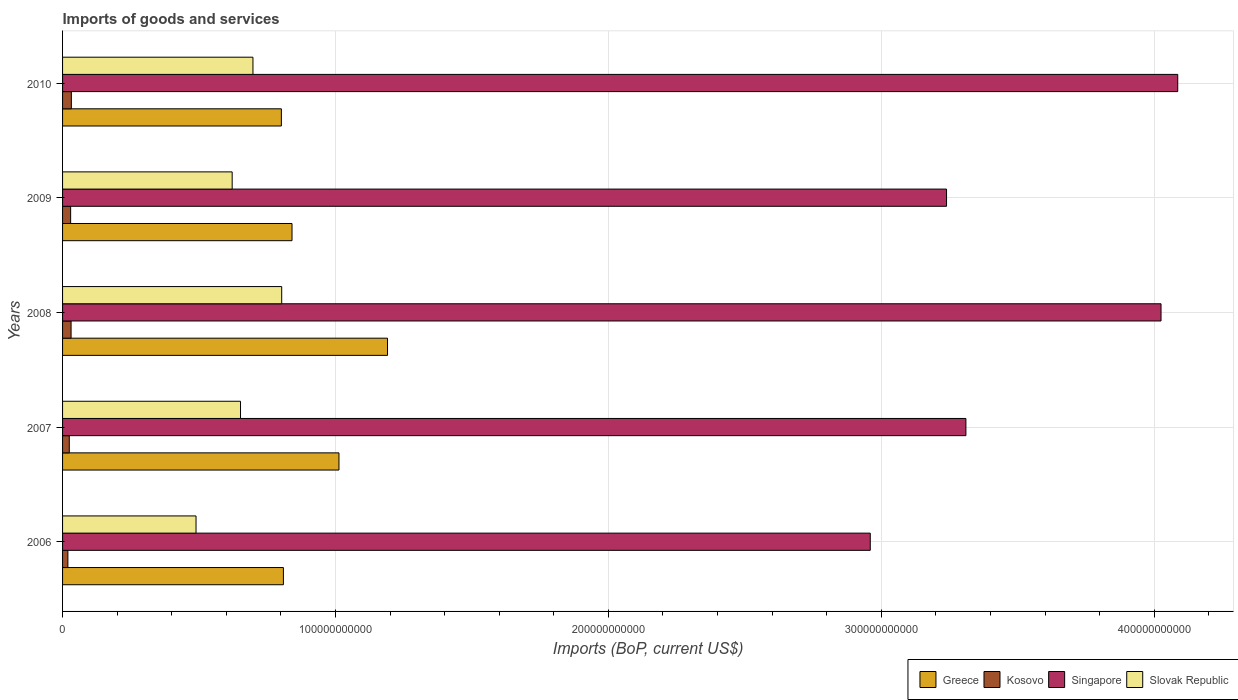Are the number of bars on each tick of the Y-axis equal?
Ensure brevity in your answer.  Yes. How many bars are there on the 1st tick from the bottom?
Give a very brief answer. 4. What is the amount spent on imports in Slovak Republic in 2010?
Make the answer very short. 6.98e+1. Across all years, what is the maximum amount spent on imports in Greece?
Ensure brevity in your answer.  1.19e+11. Across all years, what is the minimum amount spent on imports in Greece?
Your answer should be compact. 8.02e+1. In which year was the amount spent on imports in Singapore maximum?
Provide a short and direct response. 2010. In which year was the amount spent on imports in Slovak Republic minimum?
Your answer should be very brief. 2006. What is the total amount spent on imports in Slovak Republic in the graph?
Ensure brevity in your answer.  3.26e+11. What is the difference between the amount spent on imports in Singapore in 2006 and that in 2009?
Keep it short and to the point. -2.80e+1. What is the difference between the amount spent on imports in Slovak Republic in 2010 and the amount spent on imports in Singapore in 2009?
Offer a very short reply. -2.54e+11. What is the average amount spent on imports in Kosovo per year?
Give a very brief answer. 2.74e+09. In the year 2010, what is the difference between the amount spent on imports in Slovak Republic and amount spent on imports in Kosovo?
Your answer should be compact. 6.65e+1. What is the ratio of the amount spent on imports in Singapore in 2006 to that in 2010?
Make the answer very short. 0.72. Is the amount spent on imports in Slovak Republic in 2007 less than that in 2008?
Ensure brevity in your answer.  Yes. Is the difference between the amount spent on imports in Slovak Republic in 2006 and 2009 greater than the difference between the amount spent on imports in Kosovo in 2006 and 2009?
Your answer should be very brief. No. What is the difference between the highest and the second highest amount spent on imports in Kosovo?
Provide a short and direct response. 1.03e+08. What is the difference between the highest and the lowest amount spent on imports in Singapore?
Your response must be concise. 1.13e+11. In how many years, is the amount spent on imports in Kosovo greater than the average amount spent on imports in Kosovo taken over all years?
Provide a succinct answer. 3. Is the sum of the amount spent on imports in Greece in 2007 and 2008 greater than the maximum amount spent on imports in Singapore across all years?
Your answer should be very brief. No. Is it the case that in every year, the sum of the amount spent on imports in Greece and amount spent on imports in Slovak Republic is greater than the sum of amount spent on imports in Singapore and amount spent on imports in Kosovo?
Provide a succinct answer. Yes. What does the 1st bar from the top in 2007 represents?
Provide a succinct answer. Slovak Republic. What does the 3rd bar from the bottom in 2006 represents?
Ensure brevity in your answer.  Singapore. How many bars are there?
Provide a short and direct response. 20. How many years are there in the graph?
Your answer should be very brief. 5. What is the difference between two consecutive major ticks on the X-axis?
Your answer should be compact. 1.00e+11. Are the values on the major ticks of X-axis written in scientific E-notation?
Give a very brief answer. No. Does the graph contain grids?
Ensure brevity in your answer.  Yes. Where does the legend appear in the graph?
Your answer should be compact. Bottom right. How many legend labels are there?
Offer a very short reply. 4. What is the title of the graph?
Offer a very short reply. Imports of goods and services. What is the label or title of the X-axis?
Your answer should be very brief. Imports (BoP, current US$). What is the label or title of the Y-axis?
Ensure brevity in your answer.  Years. What is the Imports (BoP, current US$) in Greece in 2006?
Ensure brevity in your answer.  8.09e+1. What is the Imports (BoP, current US$) of Kosovo in 2006?
Provide a succinct answer. 1.95e+09. What is the Imports (BoP, current US$) in Singapore in 2006?
Offer a terse response. 2.96e+11. What is the Imports (BoP, current US$) of Slovak Republic in 2006?
Make the answer very short. 4.89e+1. What is the Imports (BoP, current US$) in Greece in 2007?
Your answer should be compact. 1.01e+11. What is the Imports (BoP, current US$) in Kosovo in 2007?
Ensure brevity in your answer.  2.46e+09. What is the Imports (BoP, current US$) in Singapore in 2007?
Give a very brief answer. 3.31e+11. What is the Imports (BoP, current US$) in Slovak Republic in 2007?
Provide a succinct answer. 6.52e+1. What is the Imports (BoP, current US$) in Greece in 2008?
Provide a short and direct response. 1.19e+11. What is the Imports (BoP, current US$) of Kosovo in 2008?
Give a very brief answer. 3.12e+09. What is the Imports (BoP, current US$) of Singapore in 2008?
Ensure brevity in your answer.  4.03e+11. What is the Imports (BoP, current US$) in Slovak Republic in 2008?
Provide a short and direct response. 8.03e+1. What is the Imports (BoP, current US$) of Greece in 2009?
Keep it short and to the point. 8.41e+1. What is the Imports (BoP, current US$) in Kosovo in 2009?
Ensure brevity in your answer.  2.96e+09. What is the Imports (BoP, current US$) of Singapore in 2009?
Your response must be concise. 3.24e+11. What is the Imports (BoP, current US$) of Slovak Republic in 2009?
Offer a very short reply. 6.21e+1. What is the Imports (BoP, current US$) of Greece in 2010?
Your answer should be compact. 8.02e+1. What is the Imports (BoP, current US$) in Kosovo in 2010?
Keep it short and to the point. 3.22e+09. What is the Imports (BoP, current US$) of Singapore in 2010?
Keep it short and to the point. 4.09e+11. What is the Imports (BoP, current US$) in Slovak Republic in 2010?
Provide a short and direct response. 6.98e+1. Across all years, what is the maximum Imports (BoP, current US$) in Greece?
Your answer should be compact. 1.19e+11. Across all years, what is the maximum Imports (BoP, current US$) of Kosovo?
Offer a very short reply. 3.22e+09. Across all years, what is the maximum Imports (BoP, current US$) in Singapore?
Ensure brevity in your answer.  4.09e+11. Across all years, what is the maximum Imports (BoP, current US$) in Slovak Republic?
Offer a very short reply. 8.03e+1. Across all years, what is the minimum Imports (BoP, current US$) in Greece?
Offer a very short reply. 8.02e+1. Across all years, what is the minimum Imports (BoP, current US$) of Kosovo?
Make the answer very short. 1.95e+09. Across all years, what is the minimum Imports (BoP, current US$) in Singapore?
Ensure brevity in your answer.  2.96e+11. Across all years, what is the minimum Imports (BoP, current US$) of Slovak Republic?
Your answer should be compact. 4.89e+1. What is the total Imports (BoP, current US$) of Greece in the graph?
Ensure brevity in your answer.  4.66e+11. What is the total Imports (BoP, current US$) of Kosovo in the graph?
Your response must be concise. 1.37e+1. What is the total Imports (BoP, current US$) of Singapore in the graph?
Your answer should be compact. 1.76e+12. What is the total Imports (BoP, current US$) in Slovak Republic in the graph?
Make the answer very short. 3.26e+11. What is the difference between the Imports (BoP, current US$) of Greece in 2006 and that in 2007?
Keep it short and to the point. -2.04e+1. What is the difference between the Imports (BoP, current US$) of Kosovo in 2006 and that in 2007?
Your answer should be very brief. -5.10e+08. What is the difference between the Imports (BoP, current US$) in Singapore in 2006 and that in 2007?
Ensure brevity in your answer.  -3.50e+1. What is the difference between the Imports (BoP, current US$) in Slovak Republic in 2006 and that in 2007?
Offer a terse response. -1.63e+1. What is the difference between the Imports (BoP, current US$) in Greece in 2006 and that in 2008?
Your response must be concise. -3.81e+1. What is the difference between the Imports (BoP, current US$) of Kosovo in 2006 and that in 2008?
Ensure brevity in your answer.  -1.17e+09. What is the difference between the Imports (BoP, current US$) of Singapore in 2006 and that in 2008?
Keep it short and to the point. -1.07e+11. What is the difference between the Imports (BoP, current US$) of Slovak Republic in 2006 and that in 2008?
Give a very brief answer. -3.14e+1. What is the difference between the Imports (BoP, current US$) of Greece in 2006 and that in 2009?
Your answer should be very brief. -3.16e+09. What is the difference between the Imports (BoP, current US$) of Kosovo in 2006 and that in 2009?
Provide a succinct answer. -1.01e+09. What is the difference between the Imports (BoP, current US$) in Singapore in 2006 and that in 2009?
Offer a very short reply. -2.80e+1. What is the difference between the Imports (BoP, current US$) in Slovak Republic in 2006 and that in 2009?
Offer a very short reply. -1.32e+1. What is the difference between the Imports (BoP, current US$) of Greece in 2006 and that in 2010?
Offer a terse response. 7.44e+08. What is the difference between the Imports (BoP, current US$) in Kosovo in 2006 and that in 2010?
Your answer should be very brief. -1.27e+09. What is the difference between the Imports (BoP, current US$) of Singapore in 2006 and that in 2010?
Give a very brief answer. -1.13e+11. What is the difference between the Imports (BoP, current US$) of Slovak Republic in 2006 and that in 2010?
Your answer should be very brief. -2.09e+1. What is the difference between the Imports (BoP, current US$) of Greece in 2007 and that in 2008?
Your answer should be compact. -1.78e+1. What is the difference between the Imports (BoP, current US$) of Kosovo in 2007 and that in 2008?
Your response must be concise. -6.61e+08. What is the difference between the Imports (BoP, current US$) of Singapore in 2007 and that in 2008?
Provide a succinct answer. -7.15e+1. What is the difference between the Imports (BoP, current US$) in Slovak Republic in 2007 and that in 2008?
Make the answer very short. -1.51e+1. What is the difference between the Imports (BoP, current US$) in Greece in 2007 and that in 2009?
Offer a very short reply. 1.72e+1. What is the difference between the Imports (BoP, current US$) of Kosovo in 2007 and that in 2009?
Your answer should be compact. -5.01e+08. What is the difference between the Imports (BoP, current US$) in Singapore in 2007 and that in 2009?
Ensure brevity in your answer.  7.10e+09. What is the difference between the Imports (BoP, current US$) of Slovak Republic in 2007 and that in 2009?
Your answer should be compact. 3.06e+09. What is the difference between the Imports (BoP, current US$) of Greece in 2007 and that in 2010?
Your answer should be compact. 2.11e+1. What is the difference between the Imports (BoP, current US$) in Kosovo in 2007 and that in 2010?
Your response must be concise. -7.63e+08. What is the difference between the Imports (BoP, current US$) in Singapore in 2007 and that in 2010?
Give a very brief answer. -7.76e+1. What is the difference between the Imports (BoP, current US$) in Slovak Republic in 2007 and that in 2010?
Your answer should be very brief. -4.56e+09. What is the difference between the Imports (BoP, current US$) of Greece in 2008 and that in 2009?
Give a very brief answer. 3.50e+1. What is the difference between the Imports (BoP, current US$) in Kosovo in 2008 and that in 2009?
Your answer should be compact. 1.59e+08. What is the difference between the Imports (BoP, current US$) in Singapore in 2008 and that in 2009?
Your answer should be compact. 7.86e+1. What is the difference between the Imports (BoP, current US$) of Slovak Republic in 2008 and that in 2009?
Provide a succinct answer. 1.81e+1. What is the difference between the Imports (BoP, current US$) of Greece in 2008 and that in 2010?
Offer a terse response. 3.89e+1. What is the difference between the Imports (BoP, current US$) in Kosovo in 2008 and that in 2010?
Your answer should be very brief. -1.03e+08. What is the difference between the Imports (BoP, current US$) of Singapore in 2008 and that in 2010?
Offer a terse response. -6.12e+09. What is the difference between the Imports (BoP, current US$) of Slovak Republic in 2008 and that in 2010?
Your answer should be compact. 1.05e+1. What is the difference between the Imports (BoP, current US$) in Greece in 2009 and that in 2010?
Offer a very short reply. 3.90e+09. What is the difference between the Imports (BoP, current US$) of Kosovo in 2009 and that in 2010?
Offer a very short reply. -2.62e+08. What is the difference between the Imports (BoP, current US$) in Singapore in 2009 and that in 2010?
Your answer should be compact. -8.47e+1. What is the difference between the Imports (BoP, current US$) of Slovak Republic in 2009 and that in 2010?
Offer a terse response. -7.61e+09. What is the difference between the Imports (BoP, current US$) of Greece in 2006 and the Imports (BoP, current US$) of Kosovo in 2007?
Ensure brevity in your answer.  7.85e+1. What is the difference between the Imports (BoP, current US$) in Greece in 2006 and the Imports (BoP, current US$) in Singapore in 2007?
Keep it short and to the point. -2.50e+11. What is the difference between the Imports (BoP, current US$) in Greece in 2006 and the Imports (BoP, current US$) in Slovak Republic in 2007?
Your response must be concise. 1.57e+1. What is the difference between the Imports (BoP, current US$) in Kosovo in 2006 and the Imports (BoP, current US$) in Singapore in 2007?
Provide a short and direct response. -3.29e+11. What is the difference between the Imports (BoP, current US$) in Kosovo in 2006 and the Imports (BoP, current US$) in Slovak Republic in 2007?
Offer a terse response. -6.33e+1. What is the difference between the Imports (BoP, current US$) of Singapore in 2006 and the Imports (BoP, current US$) of Slovak Republic in 2007?
Your response must be concise. 2.31e+11. What is the difference between the Imports (BoP, current US$) of Greece in 2006 and the Imports (BoP, current US$) of Kosovo in 2008?
Offer a terse response. 7.78e+1. What is the difference between the Imports (BoP, current US$) in Greece in 2006 and the Imports (BoP, current US$) in Singapore in 2008?
Your answer should be compact. -3.22e+11. What is the difference between the Imports (BoP, current US$) in Greece in 2006 and the Imports (BoP, current US$) in Slovak Republic in 2008?
Offer a terse response. 6.22e+08. What is the difference between the Imports (BoP, current US$) of Kosovo in 2006 and the Imports (BoP, current US$) of Singapore in 2008?
Offer a very short reply. -4.01e+11. What is the difference between the Imports (BoP, current US$) in Kosovo in 2006 and the Imports (BoP, current US$) in Slovak Republic in 2008?
Ensure brevity in your answer.  -7.83e+1. What is the difference between the Imports (BoP, current US$) in Singapore in 2006 and the Imports (BoP, current US$) in Slovak Republic in 2008?
Provide a short and direct response. 2.16e+11. What is the difference between the Imports (BoP, current US$) of Greece in 2006 and the Imports (BoP, current US$) of Kosovo in 2009?
Keep it short and to the point. 7.80e+1. What is the difference between the Imports (BoP, current US$) of Greece in 2006 and the Imports (BoP, current US$) of Singapore in 2009?
Offer a very short reply. -2.43e+11. What is the difference between the Imports (BoP, current US$) of Greece in 2006 and the Imports (BoP, current US$) of Slovak Republic in 2009?
Offer a terse response. 1.88e+1. What is the difference between the Imports (BoP, current US$) of Kosovo in 2006 and the Imports (BoP, current US$) of Singapore in 2009?
Offer a very short reply. -3.22e+11. What is the difference between the Imports (BoP, current US$) in Kosovo in 2006 and the Imports (BoP, current US$) in Slovak Republic in 2009?
Provide a short and direct response. -6.02e+1. What is the difference between the Imports (BoP, current US$) in Singapore in 2006 and the Imports (BoP, current US$) in Slovak Republic in 2009?
Your response must be concise. 2.34e+11. What is the difference between the Imports (BoP, current US$) in Greece in 2006 and the Imports (BoP, current US$) in Kosovo in 2010?
Make the answer very short. 7.77e+1. What is the difference between the Imports (BoP, current US$) in Greece in 2006 and the Imports (BoP, current US$) in Singapore in 2010?
Provide a short and direct response. -3.28e+11. What is the difference between the Imports (BoP, current US$) in Greece in 2006 and the Imports (BoP, current US$) in Slovak Republic in 2010?
Provide a succinct answer. 1.12e+1. What is the difference between the Imports (BoP, current US$) of Kosovo in 2006 and the Imports (BoP, current US$) of Singapore in 2010?
Keep it short and to the point. -4.07e+11. What is the difference between the Imports (BoP, current US$) of Kosovo in 2006 and the Imports (BoP, current US$) of Slovak Republic in 2010?
Offer a terse response. -6.78e+1. What is the difference between the Imports (BoP, current US$) of Singapore in 2006 and the Imports (BoP, current US$) of Slovak Republic in 2010?
Offer a terse response. 2.26e+11. What is the difference between the Imports (BoP, current US$) of Greece in 2007 and the Imports (BoP, current US$) of Kosovo in 2008?
Your answer should be very brief. 9.82e+1. What is the difference between the Imports (BoP, current US$) of Greece in 2007 and the Imports (BoP, current US$) of Singapore in 2008?
Give a very brief answer. -3.01e+11. What is the difference between the Imports (BoP, current US$) of Greece in 2007 and the Imports (BoP, current US$) of Slovak Republic in 2008?
Make the answer very short. 2.10e+1. What is the difference between the Imports (BoP, current US$) of Kosovo in 2007 and the Imports (BoP, current US$) of Singapore in 2008?
Give a very brief answer. -4.00e+11. What is the difference between the Imports (BoP, current US$) in Kosovo in 2007 and the Imports (BoP, current US$) in Slovak Republic in 2008?
Offer a very short reply. -7.78e+1. What is the difference between the Imports (BoP, current US$) of Singapore in 2007 and the Imports (BoP, current US$) of Slovak Republic in 2008?
Your answer should be compact. 2.51e+11. What is the difference between the Imports (BoP, current US$) of Greece in 2007 and the Imports (BoP, current US$) of Kosovo in 2009?
Provide a short and direct response. 9.83e+1. What is the difference between the Imports (BoP, current US$) of Greece in 2007 and the Imports (BoP, current US$) of Singapore in 2009?
Your response must be concise. -2.23e+11. What is the difference between the Imports (BoP, current US$) in Greece in 2007 and the Imports (BoP, current US$) in Slovak Republic in 2009?
Ensure brevity in your answer.  3.91e+1. What is the difference between the Imports (BoP, current US$) in Kosovo in 2007 and the Imports (BoP, current US$) in Singapore in 2009?
Offer a very short reply. -3.21e+11. What is the difference between the Imports (BoP, current US$) in Kosovo in 2007 and the Imports (BoP, current US$) in Slovak Republic in 2009?
Provide a succinct answer. -5.97e+1. What is the difference between the Imports (BoP, current US$) in Singapore in 2007 and the Imports (BoP, current US$) in Slovak Republic in 2009?
Ensure brevity in your answer.  2.69e+11. What is the difference between the Imports (BoP, current US$) in Greece in 2007 and the Imports (BoP, current US$) in Kosovo in 2010?
Offer a very short reply. 9.81e+1. What is the difference between the Imports (BoP, current US$) of Greece in 2007 and the Imports (BoP, current US$) of Singapore in 2010?
Give a very brief answer. -3.07e+11. What is the difference between the Imports (BoP, current US$) in Greece in 2007 and the Imports (BoP, current US$) in Slovak Republic in 2010?
Provide a succinct answer. 3.15e+1. What is the difference between the Imports (BoP, current US$) in Kosovo in 2007 and the Imports (BoP, current US$) in Singapore in 2010?
Your answer should be very brief. -4.06e+11. What is the difference between the Imports (BoP, current US$) in Kosovo in 2007 and the Imports (BoP, current US$) in Slovak Republic in 2010?
Ensure brevity in your answer.  -6.73e+1. What is the difference between the Imports (BoP, current US$) in Singapore in 2007 and the Imports (BoP, current US$) in Slovak Republic in 2010?
Ensure brevity in your answer.  2.61e+11. What is the difference between the Imports (BoP, current US$) of Greece in 2008 and the Imports (BoP, current US$) of Kosovo in 2009?
Offer a very short reply. 1.16e+11. What is the difference between the Imports (BoP, current US$) in Greece in 2008 and the Imports (BoP, current US$) in Singapore in 2009?
Make the answer very short. -2.05e+11. What is the difference between the Imports (BoP, current US$) in Greece in 2008 and the Imports (BoP, current US$) in Slovak Republic in 2009?
Make the answer very short. 5.69e+1. What is the difference between the Imports (BoP, current US$) in Kosovo in 2008 and the Imports (BoP, current US$) in Singapore in 2009?
Give a very brief answer. -3.21e+11. What is the difference between the Imports (BoP, current US$) of Kosovo in 2008 and the Imports (BoP, current US$) of Slovak Republic in 2009?
Offer a terse response. -5.90e+1. What is the difference between the Imports (BoP, current US$) of Singapore in 2008 and the Imports (BoP, current US$) of Slovak Republic in 2009?
Ensure brevity in your answer.  3.40e+11. What is the difference between the Imports (BoP, current US$) of Greece in 2008 and the Imports (BoP, current US$) of Kosovo in 2010?
Offer a terse response. 1.16e+11. What is the difference between the Imports (BoP, current US$) in Greece in 2008 and the Imports (BoP, current US$) in Singapore in 2010?
Your response must be concise. -2.90e+11. What is the difference between the Imports (BoP, current US$) of Greece in 2008 and the Imports (BoP, current US$) of Slovak Republic in 2010?
Make the answer very short. 4.93e+1. What is the difference between the Imports (BoP, current US$) of Kosovo in 2008 and the Imports (BoP, current US$) of Singapore in 2010?
Ensure brevity in your answer.  -4.06e+11. What is the difference between the Imports (BoP, current US$) in Kosovo in 2008 and the Imports (BoP, current US$) in Slovak Republic in 2010?
Make the answer very short. -6.66e+1. What is the difference between the Imports (BoP, current US$) in Singapore in 2008 and the Imports (BoP, current US$) in Slovak Republic in 2010?
Keep it short and to the point. 3.33e+11. What is the difference between the Imports (BoP, current US$) in Greece in 2009 and the Imports (BoP, current US$) in Kosovo in 2010?
Keep it short and to the point. 8.09e+1. What is the difference between the Imports (BoP, current US$) in Greece in 2009 and the Imports (BoP, current US$) in Singapore in 2010?
Your answer should be very brief. -3.25e+11. What is the difference between the Imports (BoP, current US$) of Greece in 2009 and the Imports (BoP, current US$) of Slovak Republic in 2010?
Your answer should be very brief. 1.43e+1. What is the difference between the Imports (BoP, current US$) in Kosovo in 2009 and the Imports (BoP, current US$) in Singapore in 2010?
Your answer should be compact. -4.06e+11. What is the difference between the Imports (BoP, current US$) in Kosovo in 2009 and the Imports (BoP, current US$) in Slovak Republic in 2010?
Make the answer very short. -6.68e+1. What is the difference between the Imports (BoP, current US$) of Singapore in 2009 and the Imports (BoP, current US$) of Slovak Republic in 2010?
Keep it short and to the point. 2.54e+11. What is the average Imports (BoP, current US$) in Greece per year?
Provide a succinct answer. 9.31e+1. What is the average Imports (BoP, current US$) in Kosovo per year?
Give a very brief answer. 2.74e+09. What is the average Imports (BoP, current US$) in Singapore per year?
Offer a very short reply. 3.52e+11. What is the average Imports (BoP, current US$) in Slovak Republic per year?
Offer a very short reply. 6.53e+1. In the year 2006, what is the difference between the Imports (BoP, current US$) of Greece and Imports (BoP, current US$) of Kosovo?
Provide a short and direct response. 7.90e+1. In the year 2006, what is the difference between the Imports (BoP, current US$) of Greece and Imports (BoP, current US$) of Singapore?
Offer a terse response. -2.15e+11. In the year 2006, what is the difference between the Imports (BoP, current US$) of Greece and Imports (BoP, current US$) of Slovak Republic?
Offer a very short reply. 3.20e+1. In the year 2006, what is the difference between the Imports (BoP, current US$) of Kosovo and Imports (BoP, current US$) of Singapore?
Your response must be concise. -2.94e+11. In the year 2006, what is the difference between the Imports (BoP, current US$) of Kosovo and Imports (BoP, current US$) of Slovak Republic?
Make the answer very short. -4.70e+1. In the year 2006, what is the difference between the Imports (BoP, current US$) of Singapore and Imports (BoP, current US$) of Slovak Republic?
Make the answer very short. 2.47e+11. In the year 2007, what is the difference between the Imports (BoP, current US$) of Greece and Imports (BoP, current US$) of Kosovo?
Ensure brevity in your answer.  9.88e+1. In the year 2007, what is the difference between the Imports (BoP, current US$) of Greece and Imports (BoP, current US$) of Singapore?
Your answer should be compact. -2.30e+11. In the year 2007, what is the difference between the Imports (BoP, current US$) in Greece and Imports (BoP, current US$) in Slovak Republic?
Give a very brief answer. 3.61e+1. In the year 2007, what is the difference between the Imports (BoP, current US$) in Kosovo and Imports (BoP, current US$) in Singapore?
Make the answer very short. -3.29e+11. In the year 2007, what is the difference between the Imports (BoP, current US$) of Kosovo and Imports (BoP, current US$) of Slovak Republic?
Give a very brief answer. -6.27e+1. In the year 2007, what is the difference between the Imports (BoP, current US$) of Singapore and Imports (BoP, current US$) of Slovak Republic?
Your answer should be very brief. 2.66e+11. In the year 2008, what is the difference between the Imports (BoP, current US$) of Greece and Imports (BoP, current US$) of Kosovo?
Give a very brief answer. 1.16e+11. In the year 2008, what is the difference between the Imports (BoP, current US$) of Greece and Imports (BoP, current US$) of Singapore?
Your answer should be very brief. -2.83e+11. In the year 2008, what is the difference between the Imports (BoP, current US$) in Greece and Imports (BoP, current US$) in Slovak Republic?
Offer a terse response. 3.88e+1. In the year 2008, what is the difference between the Imports (BoP, current US$) of Kosovo and Imports (BoP, current US$) of Singapore?
Give a very brief answer. -3.99e+11. In the year 2008, what is the difference between the Imports (BoP, current US$) in Kosovo and Imports (BoP, current US$) in Slovak Republic?
Your response must be concise. -7.72e+1. In the year 2008, what is the difference between the Imports (BoP, current US$) in Singapore and Imports (BoP, current US$) in Slovak Republic?
Offer a terse response. 3.22e+11. In the year 2009, what is the difference between the Imports (BoP, current US$) of Greece and Imports (BoP, current US$) of Kosovo?
Ensure brevity in your answer.  8.11e+1. In the year 2009, what is the difference between the Imports (BoP, current US$) of Greece and Imports (BoP, current US$) of Singapore?
Make the answer very short. -2.40e+11. In the year 2009, what is the difference between the Imports (BoP, current US$) in Greece and Imports (BoP, current US$) in Slovak Republic?
Provide a short and direct response. 2.19e+1. In the year 2009, what is the difference between the Imports (BoP, current US$) in Kosovo and Imports (BoP, current US$) in Singapore?
Offer a very short reply. -3.21e+11. In the year 2009, what is the difference between the Imports (BoP, current US$) of Kosovo and Imports (BoP, current US$) of Slovak Republic?
Your response must be concise. -5.92e+1. In the year 2009, what is the difference between the Imports (BoP, current US$) in Singapore and Imports (BoP, current US$) in Slovak Republic?
Your response must be concise. 2.62e+11. In the year 2010, what is the difference between the Imports (BoP, current US$) in Greece and Imports (BoP, current US$) in Kosovo?
Give a very brief answer. 7.70e+1. In the year 2010, what is the difference between the Imports (BoP, current US$) of Greece and Imports (BoP, current US$) of Singapore?
Provide a succinct answer. -3.28e+11. In the year 2010, what is the difference between the Imports (BoP, current US$) of Greece and Imports (BoP, current US$) of Slovak Republic?
Your answer should be compact. 1.04e+1. In the year 2010, what is the difference between the Imports (BoP, current US$) in Kosovo and Imports (BoP, current US$) in Singapore?
Make the answer very short. -4.05e+11. In the year 2010, what is the difference between the Imports (BoP, current US$) of Kosovo and Imports (BoP, current US$) of Slovak Republic?
Your answer should be very brief. -6.65e+1. In the year 2010, what is the difference between the Imports (BoP, current US$) of Singapore and Imports (BoP, current US$) of Slovak Republic?
Keep it short and to the point. 3.39e+11. What is the ratio of the Imports (BoP, current US$) in Greece in 2006 to that in 2007?
Make the answer very short. 0.8. What is the ratio of the Imports (BoP, current US$) of Kosovo in 2006 to that in 2007?
Offer a very short reply. 0.79. What is the ratio of the Imports (BoP, current US$) in Singapore in 2006 to that in 2007?
Keep it short and to the point. 0.89. What is the ratio of the Imports (BoP, current US$) in Slovak Republic in 2006 to that in 2007?
Make the answer very short. 0.75. What is the ratio of the Imports (BoP, current US$) of Greece in 2006 to that in 2008?
Provide a succinct answer. 0.68. What is the ratio of the Imports (BoP, current US$) in Kosovo in 2006 to that in 2008?
Ensure brevity in your answer.  0.62. What is the ratio of the Imports (BoP, current US$) of Singapore in 2006 to that in 2008?
Your answer should be very brief. 0.74. What is the ratio of the Imports (BoP, current US$) in Slovak Republic in 2006 to that in 2008?
Offer a terse response. 0.61. What is the ratio of the Imports (BoP, current US$) in Greece in 2006 to that in 2009?
Your answer should be compact. 0.96. What is the ratio of the Imports (BoP, current US$) of Kosovo in 2006 to that in 2009?
Your response must be concise. 0.66. What is the ratio of the Imports (BoP, current US$) in Singapore in 2006 to that in 2009?
Give a very brief answer. 0.91. What is the ratio of the Imports (BoP, current US$) in Slovak Republic in 2006 to that in 2009?
Ensure brevity in your answer.  0.79. What is the ratio of the Imports (BoP, current US$) of Greece in 2006 to that in 2010?
Keep it short and to the point. 1.01. What is the ratio of the Imports (BoP, current US$) of Kosovo in 2006 to that in 2010?
Offer a very short reply. 0.6. What is the ratio of the Imports (BoP, current US$) of Singapore in 2006 to that in 2010?
Offer a terse response. 0.72. What is the ratio of the Imports (BoP, current US$) in Slovak Republic in 2006 to that in 2010?
Provide a succinct answer. 0.7. What is the ratio of the Imports (BoP, current US$) of Greece in 2007 to that in 2008?
Your response must be concise. 0.85. What is the ratio of the Imports (BoP, current US$) of Kosovo in 2007 to that in 2008?
Offer a very short reply. 0.79. What is the ratio of the Imports (BoP, current US$) in Singapore in 2007 to that in 2008?
Your answer should be very brief. 0.82. What is the ratio of the Imports (BoP, current US$) in Slovak Republic in 2007 to that in 2008?
Provide a short and direct response. 0.81. What is the ratio of the Imports (BoP, current US$) of Greece in 2007 to that in 2009?
Provide a short and direct response. 1.2. What is the ratio of the Imports (BoP, current US$) of Kosovo in 2007 to that in 2009?
Keep it short and to the point. 0.83. What is the ratio of the Imports (BoP, current US$) of Singapore in 2007 to that in 2009?
Ensure brevity in your answer.  1.02. What is the ratio of the Imports (BoP, current US$) of Slovak Republic in 2007 to that in 2009?
Provide a succinct answer. 1.05. What is the ratio of the Imports (BoP, current US$) of Greece in 2007 to that in 2010?
Your answer should be very brief. 1.26. What is the ratio of the Imports (BoP, current US$) in Kosovo in 2007 to that in 2010?
Your answer should be very brief. 0.76. What is the ratio of the Imports (BoP, current US$) of Singapore in 2007 to that in 2010?
Offer a very short reply. 0.81. What is the ratio of the Imports (BoP, current US$) of Slovak Republic in 2007 to that in 2010?
Provide a short and direct response. 0.93. What is the ratio of the Imports (BoP, current US$) of Greece in 2008 to that in 2009?
Ensure brevity in your answer.  1.42. What is the ratio of the Imports (BoP, current US$) of Kosovo in 2008 to that in 2009?
Your answer should be compact. 1.05. What is the ratio of the Imports (BoP, current US$) in Singapore in 2008 to that in 2009?
Provide a succinct answer. 1.24. What is the ratio of the Imports (BoP, current US$) in Slovak Republic in 2008 to that in 2009?
Keep it short and to the point. 1.29. What is the ratio of the Imports (BoP, current US$) of Greece in 2008 to that in 2010?
Provide a short and direct response. 1.49. What is the ratio of the Imports (BoP, current US$) in Kosovo in 2008 to that in 2010?
Ensure brevity in your answer.  0.97. What is the ratio of the Imports (BoP, current US$) in Singapore in 2008 to that in 2010?
Provide a succinct answer. 0.98. What is the ratio of the Imports (BoP, current US$) of Slovak Republic in 2008 to that in 2010?
Ensure brevity in your answer.  1.15. What is the ratio of the Imports (BoP, current US$) in Greece in 2009 to that in 2010?
Offer a very short reply. 1.05. What is the ratio of the Imports (BoP, current US$) in Kosovo in 2009 to that in 2010?
Offer a terse response. 0.92. What is the ratio of the Imports (BoP, current US$) in Singapore in 2009 to that in 2010?
Your answer should be very brief. 0.79. What is the ratio of the Imports (BoP, current US$) in Slovak Republic in 2009 to that in 2010?
Keep it short and to the point. 0.89. What is the difference between the highest and the second highest Imports (BoP, current US$) of Greece?
Offer a terse response. 1.78e+1. What is the difference between the highest and the second highest Imports (BoP, current US$) in Kosovo?
Your response must be concise. 1.03e+08. What is the difference between the highest and the second highest Imports (BoP, current US$) in Singapore?
Keep it short and to the point. 6.12e+09. What is the difference between the highest and the second highest Imports (BoP, current US$) in Slovak Republic?
Give a very brief answer. 1.05e+1. What is the difference between the highest and the lowest Imports (BoP, current US$) in Greece?
Provide a succinct answer. 3.89e+1. What is the difference between the highest and the lowest Imports (BoP, current US$) of Kosovo?
Offer a very short reply. 1.27e+09. What is the difference between the highest and the lowest Imports (BoP, current US$) of Singapore?
Offer a very short reply. 1.13e+11. What is the difference between the highest and the lowest Imports (BoP, current US$) of Slovak Republic?
Provide a succinct answer. 3.14e+1. 